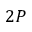Convert formula to latex. <formula><loc_0><loc_0><loc_500><loc_500>2 P</formula> 